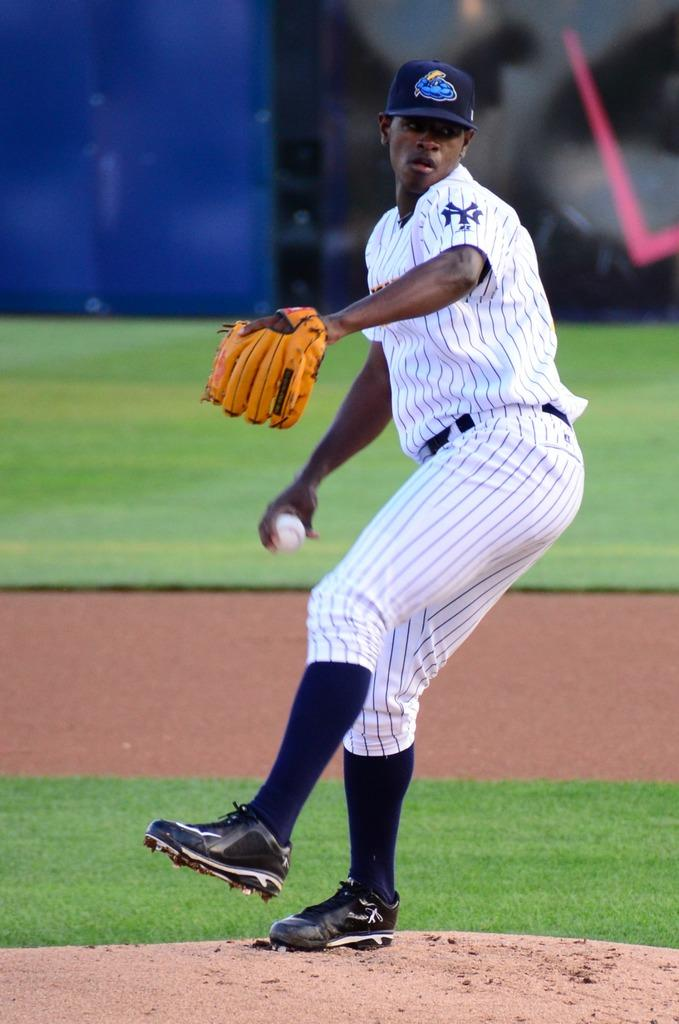<image>
Present a compact description of the photo's key features. The player from new york with the NY on his sleeve is about to pitch the ball. 